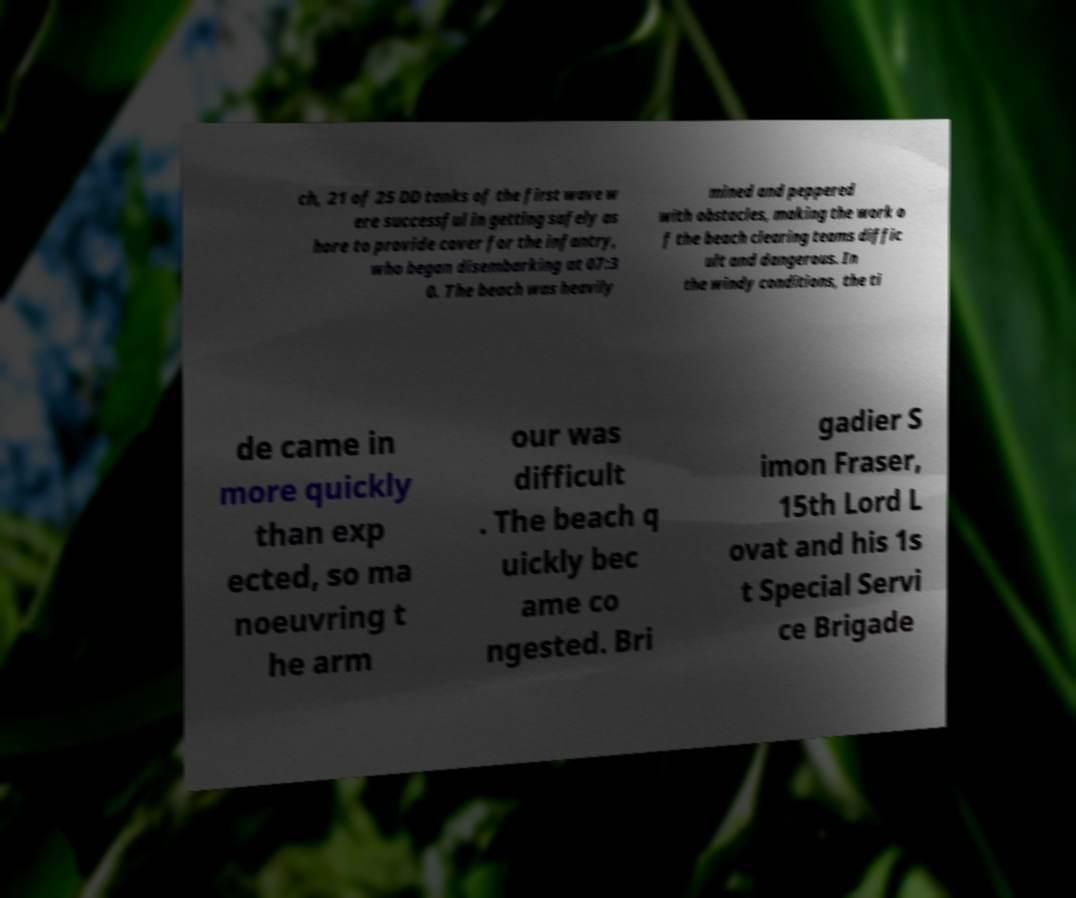I need the written content from this picture converted into text. Can you do that? ch, 21 of 25 DD tanks of the first wave w ere successful in getting safely as hore to provide cover for the infantry, who began disembarking at 07:3 0. The beach was heavily mined and peppered with obstacles, making the work o f the beach clearing teams diffic ult and dangerous. In the windy conditions, the ti de came in more quickly than exp ected, so ma noeuvring t he arm our was difficult . The beach q uickly bec ame co ngested. Bri gadier S imon Fraser, 15th Lord L ovat and his 1s t Special Servi ce Brigade 